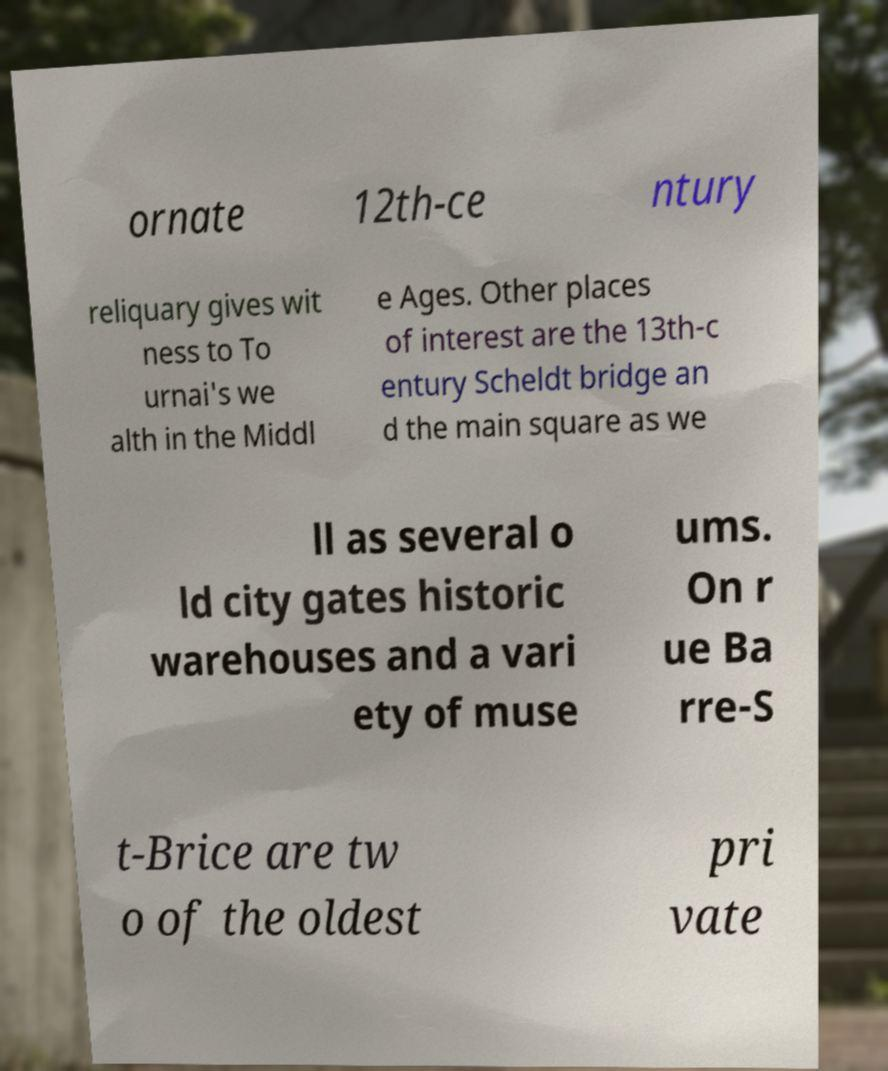Please identify and transcribe the text found in this image. ornate 12th-ce ntury reliquary gives wit ness to To urnai's we alth in the Middl e Ages. Other places of interest are the 13th-c entury Scheldt bridge an d the main square as we ll as several o ld city gates historic warehouses and a vari ety of muse ums. On r ue Ba rre-S t-Brice are tw o of the oldest pri vate 